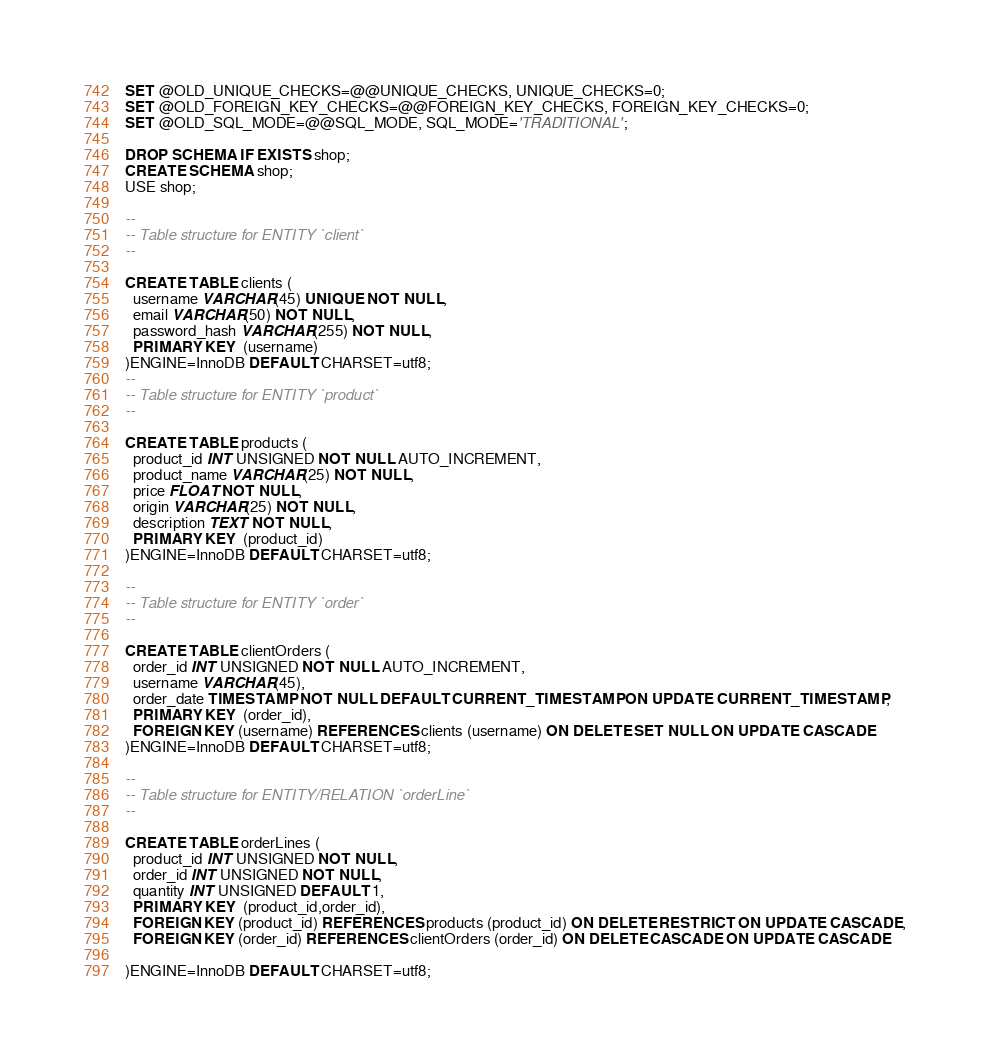<code> <loc_0><loc_0><loc_500><loc_500><_SQL_>SET @OLD_UNIQUE_CHECKS=@@UNIQUE_CHECKS, UNIQUE_CHECKS=0;
SET @OLD_FOREIGN_KEY_CHECKS=@@FOREIGN_KEY_CHECKS, FOREIGN_KEY_CHECKS=0;
SET @OLD_SQL_MODE=@@SQL_MODE, SQL_MODE='TRADITIONAL';

DROP SCHEMA IF EXISTS shop;
CREATE SCHEMA shop;
USE shop;

--
-- Table structure for ENTITY `client`
--

CREATE TABLE clients (
  username VARCHAR(45) UNIQUE NOT NULL,
  email VARCHAR(50) NOT NULL,
  password_hash VARCHAR(255) NOT NULL,
  PRIMARY KEY  (username)
)ENGINE=InnoDB DEFAULT CHARSET=utf8;
--
-- Table structure for ENTITY `product`
--

CREATE TABLE products (
  product_id INT UNSIGNED NOT NULL AUTO_INCREMENT,
  product_name VARCHAR(25) NOT NULL,
  price FLOAT NOT NULL,
  origin VARCHAR(25) NOT NULL,
  description TEXT NOT NULL, 
  PRIMARY KEY  (product_id)
)ENGINE=InnoDB DEFAULT CHARSET=utf8;

--
-- Table structure for ENTITY `order`
--

CREATE TABLE clientOrders (
  order_id INT UNSIGNED NOT NULL AUTO_INCREMENT,
  username VARCHAR(45),
  order_date TIMESTAMP NOT NULL DEFAULT CURRENT_TIMESTAMP ON UPDATE CURRENT_TIMESTAMP,
  PRIMARY KEY  (order_id),
  FOREIGN KEY (username) REFERENCES clients (username) ON DELETE SET NULL ON UPDATE CASCADE
)ENGINE=InnoDB DEFAULT CHARSET=utf8;

--
-- Table structure for ENTITY/RELATION `orderLine`
--

CREATE TABLE orderLines (
  product_id INT UNSIGNED NOT NULL,
  order_id INT UNSIGNED NOT NULL,
  quantity INT UNSIGNED DEFAULT 1,
  PRIMARY KEY  (product_id,order_id),
  FOREIGN KEY (product_id) REFERENCES products (product_id) ON DELETE RESTRICT ON UPDATE CASCADE,
  FOREIGN KEY (order_id) REFERENCES clientOrders (order_id) ON DELETE CASCADE ON UPDATE CASCADE

)ENGINE=InnoDB DEFAULT CHARSET=utf8;
</code> 